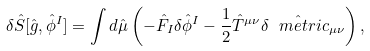Convert formula to latex. <formula><loc_0><loc_0><loc_500><loc_500>\delta \hat { S } [ { \hat { g } } , { \hat { \phi } } ^ { I } ] = \int d \hat { \mu } \left ( - \hat { F } _ { I } \delta \hat { \phi } ^ { I } - \frac { 1 } { 2 } \hat { T } ^ { \mu \nu } \delta \hat { \ m e t r i c } _ { \mu \nu } \right ) ,</formula> 